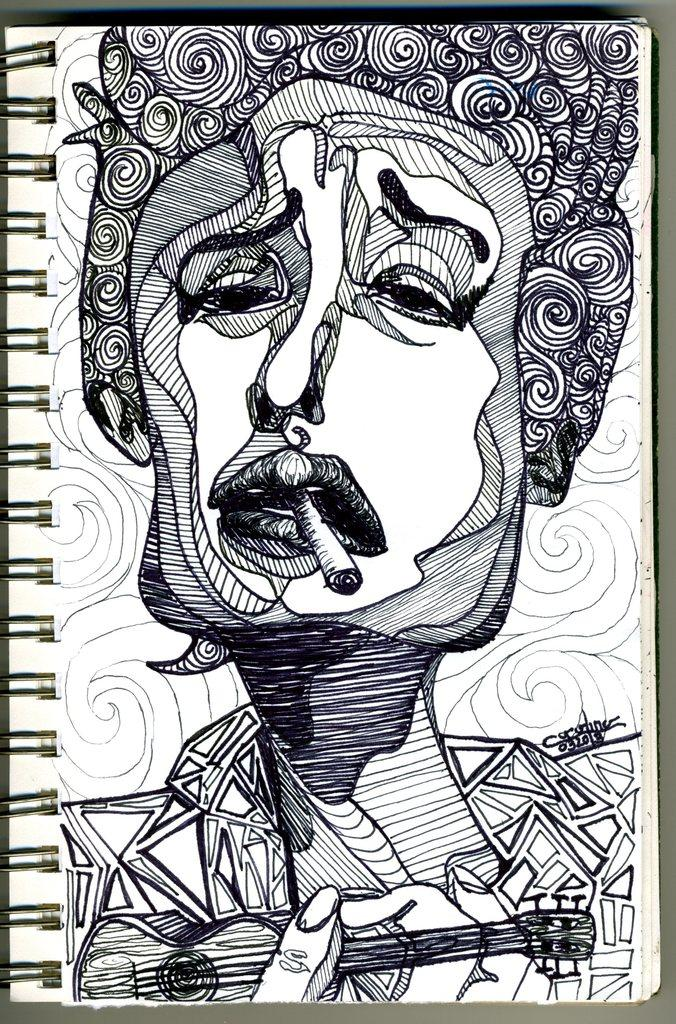What is depicted in the image? There is a drawing of a person in the image. What is the person in the drawing doing? The person in the drawing is holding a cigarette in their mouth. Can you describe the background of the image? There are designs in the background of the image. How many flies can be seen buzzing around the person in the drawing? There are no flies present in the image; it only features a drawing of a person holding a cigarette. 